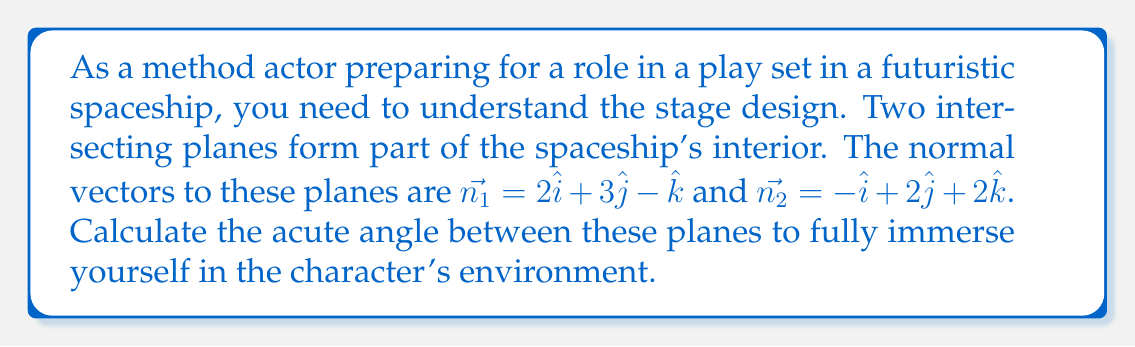Show me your answer to this math problem. To find the angle between two intersecting planes, we can use the dot product of their normal vectors. The formula is:

$$\cos \theta = \frac{|\vec{n_1} \cdot \vec{n_2}|}{|\vec{n_1}| |\vec{n_2}|}$$

Step 1: Calculate the dot product $\vec{n_1} \cdot \vec{n_2}$
$$\vec{n_1} \cdot \vec{n_2} = (2)(-1) + (3)(2) + (-1)(2) = -2 + 6 - 2 = 2$$

Step 2: Calculate the magnitudes of $\vec{n_1}$ and $\vec{n_2}$
$$|\vec{n_1}| = \sqrt{2^2 + 3^2 + (-1)^2} = \sqrt{4 + 9 + 1} = \sqrt{14}$$
$$|\vec{n_2}| = \sqrt{(-1)^2 + 2^2 + 2^2} = \sqrt{1 + 4 + 4} = 3$$

Step 3: Apply the formula
$$\cos \theta = \frac{|2|}{\sqrt{14} \cdot 3} = \frac{2}{3\sqrt{14}}$$

Step 4: Take the inverse cosine (arccos) of both sides
$$\theta = \arccos(\frac{2}{3\sqrt{14}})$$

Step 5: Calculate the result (in degrees)
$$\theta \approx 80.41°$$
Answer: $80.41°$ 